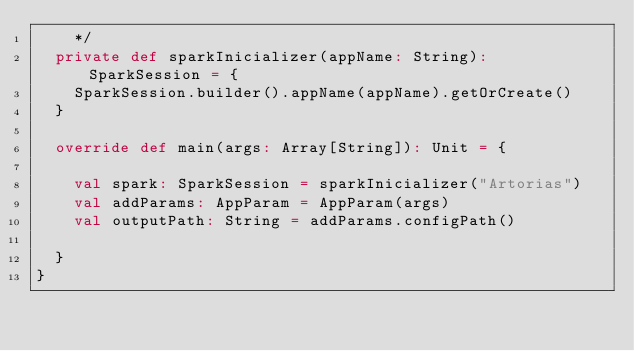Convert code to text. <code><loc_0><loc_0><loc_500><loc_500><_Scala_>    */
  private def sparkInicializer(appName: String): SparkSession = {
    SparkSession.builder().appName(appName).getOrCreate()
  }

  override def main(args: Array[String]): Unit = {

    val spark: SparkSession = sparkInicializer("Artorias")
    val addParams: AppParam = AppParam(args)
    val outputPath: String = addParams.configPath()

  }
}
</code> 